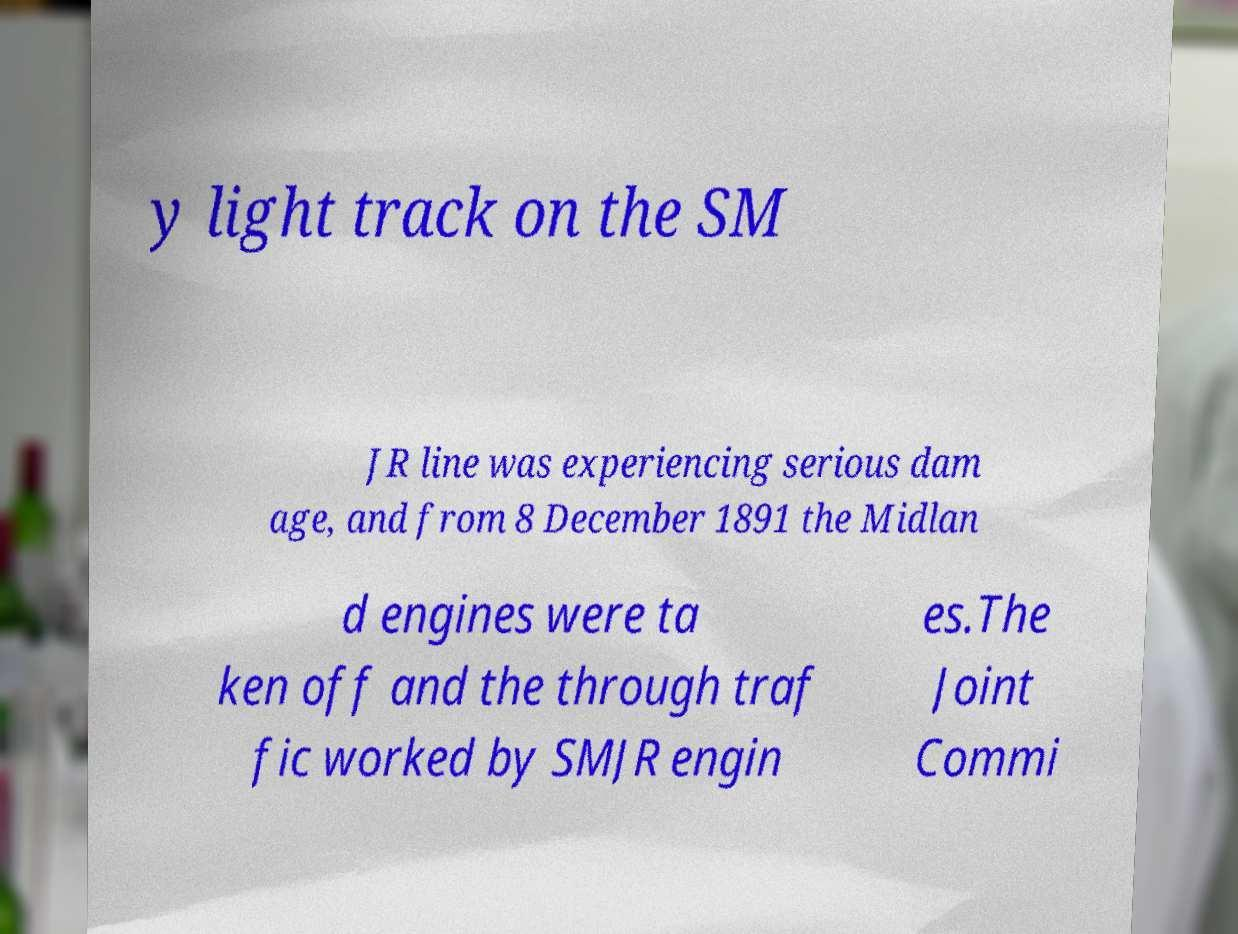Can you accurately transcribe the text from the provided image for me? y light track on the SM JR line was experiencing serious dam age, and from 8 December 1891 the Midlan d engines were ta ken off and the through traf fic worked by SMJR engin es.The Joint Commi 